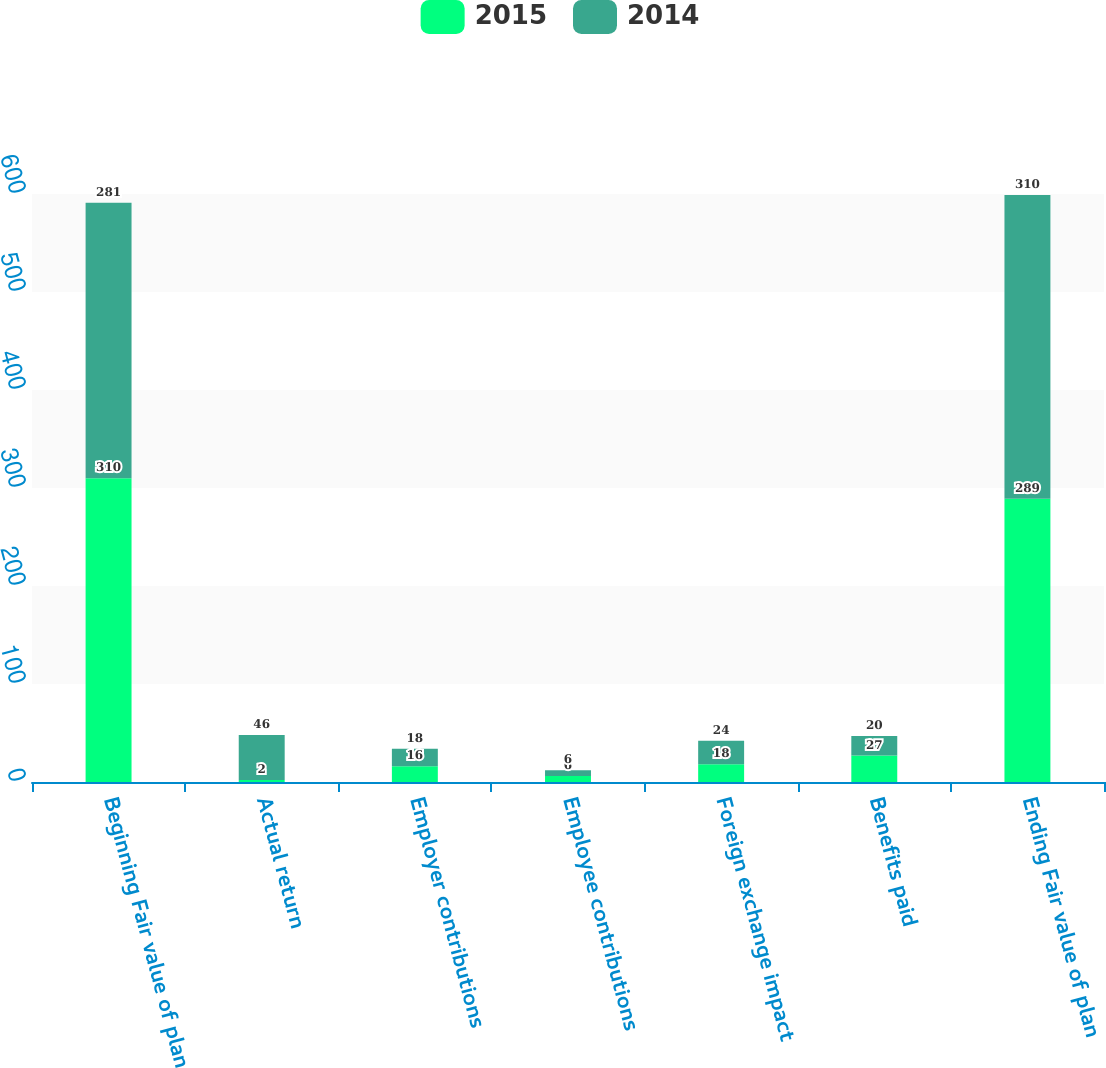Convert chart. <chart><loc_0><loc_0><loc_500><loc_500><stacked_bar_chart><ecel><fcel>Beginning Fair value of plan<fcel>Actual return<fcel>Employer contributions<fcel>Employee contributions<fcel>Foreign exchange impact<fcel>Benefits paid<fcel>Ending Fair value of plan<nl><fcel>2015<fcel>310<fcel>2<fcel>16<fcel>6<fcel>18<fcel>27<fcel>289<nl><fcel>2014<fcel>281<fcel>46<fcel>18<fcel>6<fcel>24<fcel>20<fcel>310<nl></chart> 